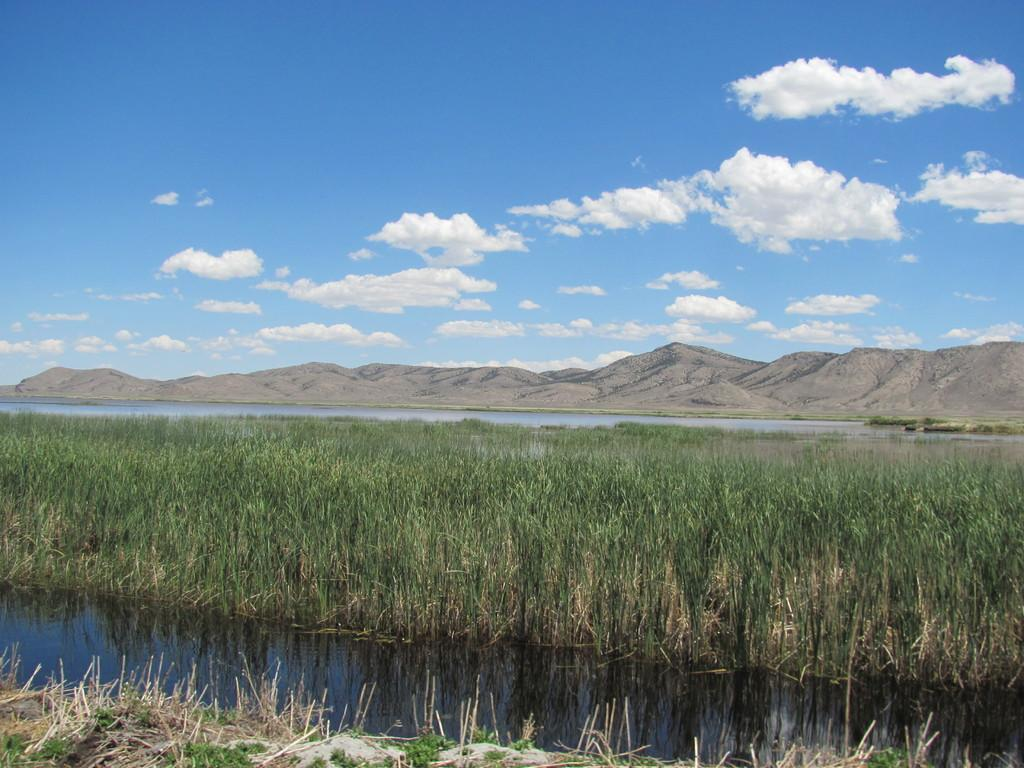What is one of the natural elements visible in the image? Water is visible in the image. What type of vegetation can be seen in the image? There is grass in the image. What geographical feature is visible behind the water? Mountains are visible behind the water. What is the condition of the sky in the image? The sky is clear and visible at the top of the image. Can you see the smile on the hill in the image? There is no hill or smile present in the image; it features water, grass, mountains, and a clear sky. 